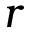Convert formula to latex. <formula><loc_0><loc_0><loc_500><loc_500>r</formula> 